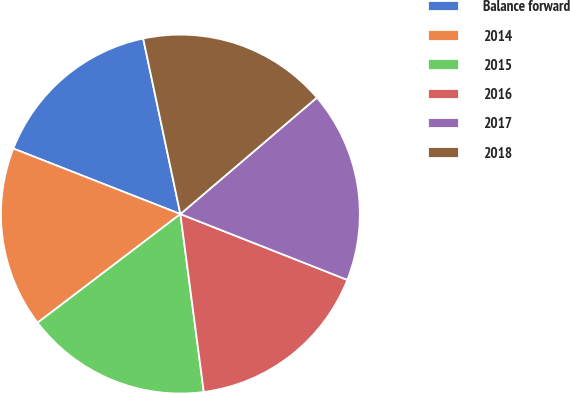<chart> <loc_0><loc_0><loc_500><loc_500><pie_chart><fcel>Balance forward<fcel>2014<fcel>2015<fcel>2016<fcel>2017<fcel>2018<nl><fcel>15.73%<fcel>16.3%<fcel>16.73%<fcel>16.94%<fcel>17.22%<fcel>17.08%<nl></chart> 